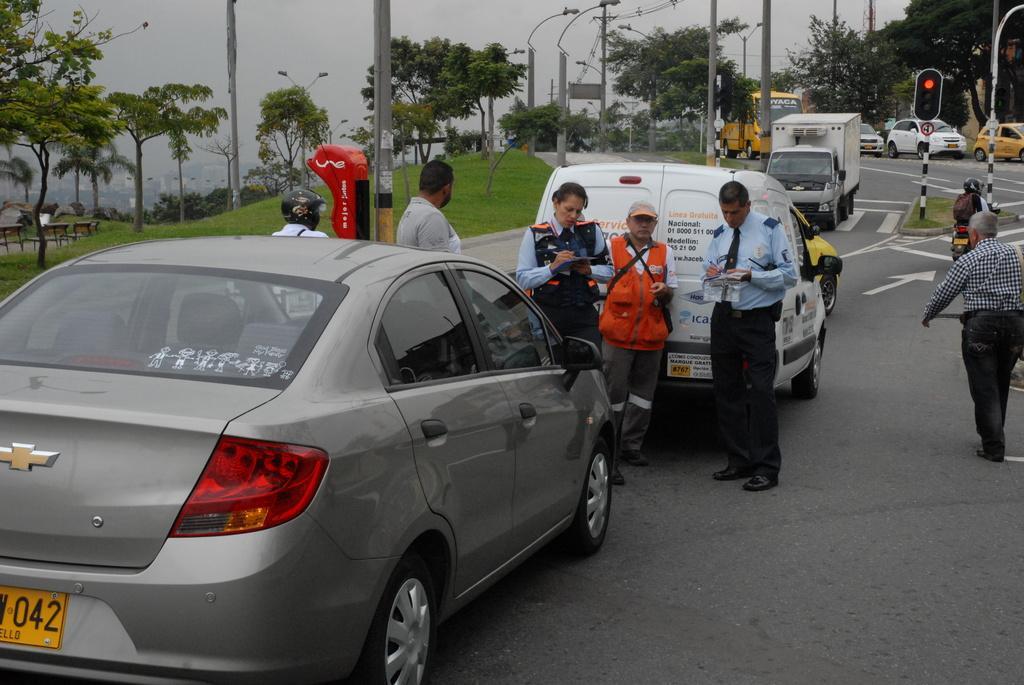How would you summarize this image in a sentence or two? In this picture there is a grey color car on the road. Behind there are two police officers writing something on the papers. Behind there are some cars on the road. On the left side there is a small garden with some trees and trees. In the background there are some electric poles. 